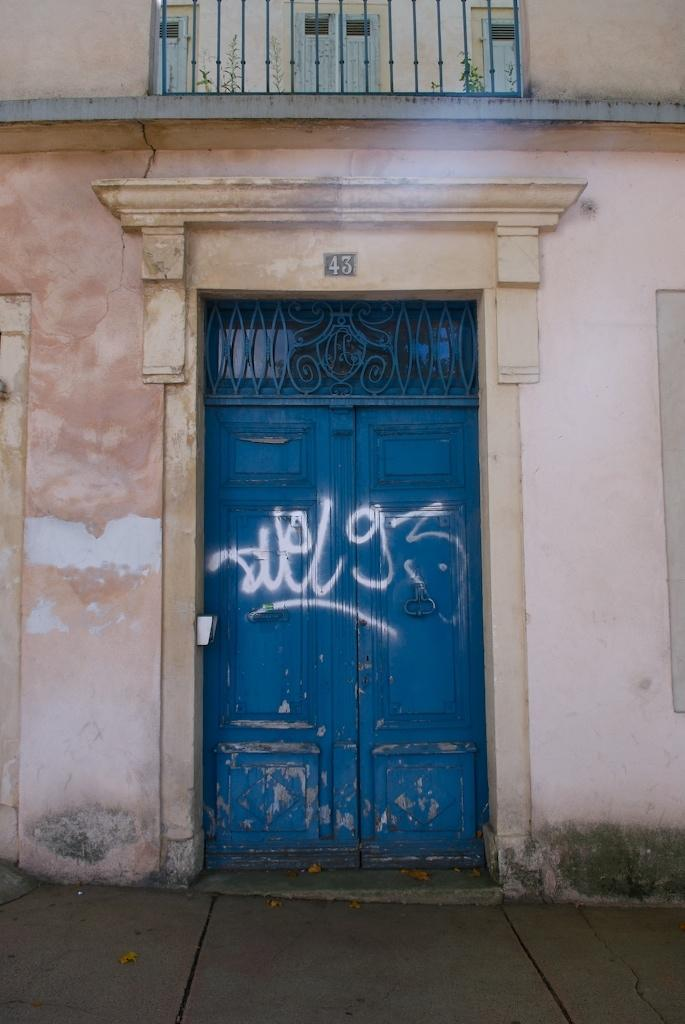What type of objects can be seen in the image? There are metal rods and doors in the image. What is the purpose of the metal rods? The purpose of the metal rods is not explicitly stated, but they may be part of a structure or framework. What is written on the doors? There is text on the doors, but the specific content of the text is not mentioned. What type of vegetation is visible at the top of the image? There are plants visible at the top of the image. Can you see a dog playing with a bridge in the image? No, there is no dog or bridge present in the image. What type of oven is used to cook the plants in the image? There is no oven or cooking mentioned in the image; the plants are simply visible at the top of the image. 